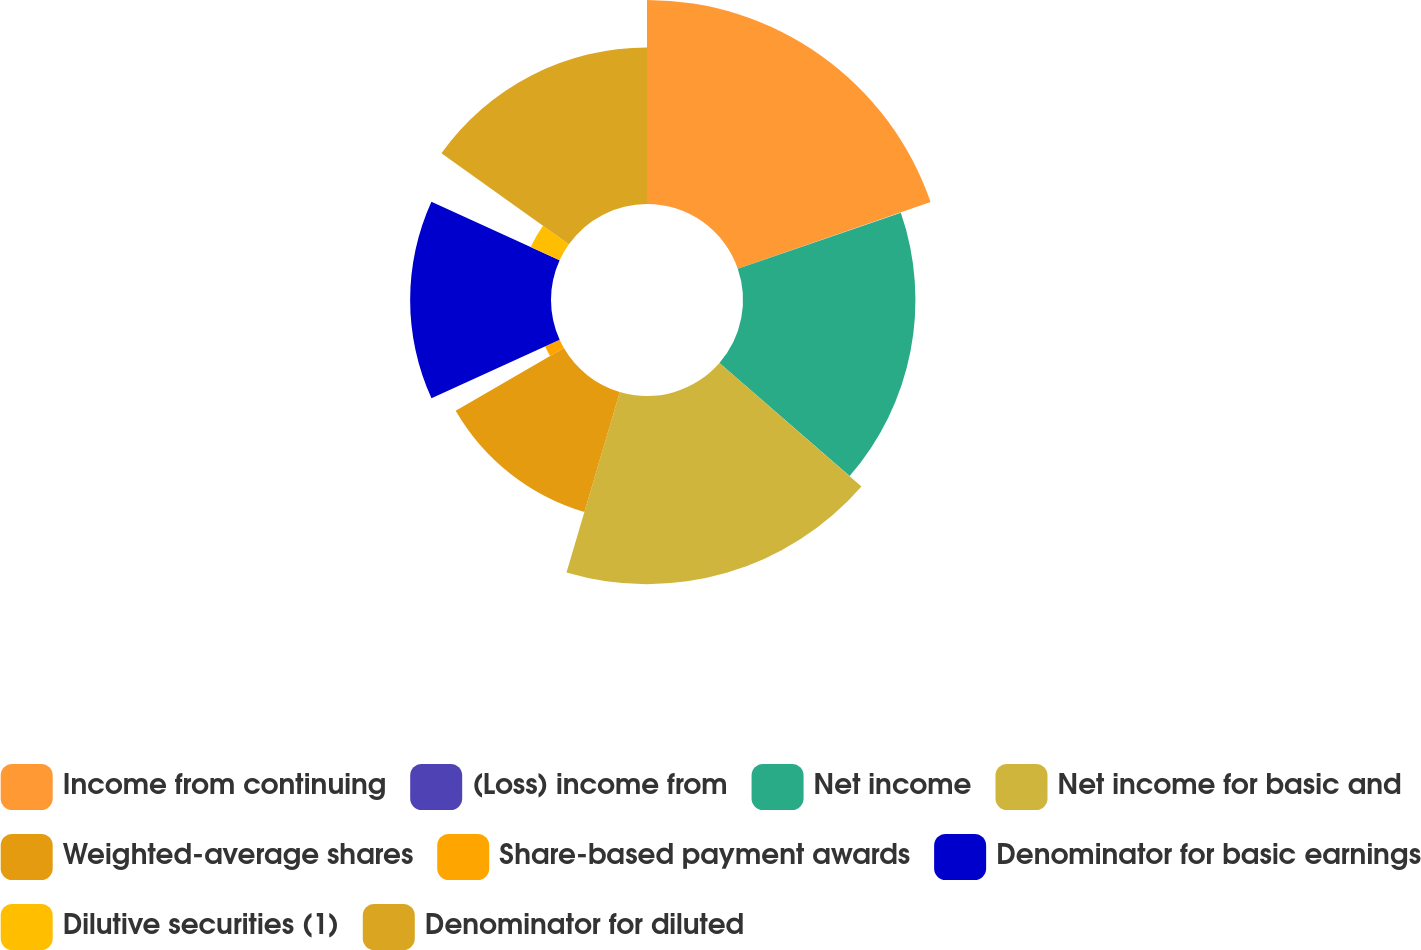<chart> <loc_0><loc_0><loc_500><loc_500><pie_chart><fcel>Income from continuing<fcel>(Loss) income from<fcel>Net income<fcel>Net income for basic and<fcel>Weighted-average shares<fcel>Share-based payment awards<fcel>Denominator for basic earnings<fcel>Dilutive securities (1)<fcel>Denominator for diluted<nl><fcel>19.71%<fcel>0.02%<fcel>16.66%<fcel>18.18%<fcel>12.08%<fcel>1.54%<fcel>13.61%<fcel>3.07%<fcel>15.13%<nl></chart> 